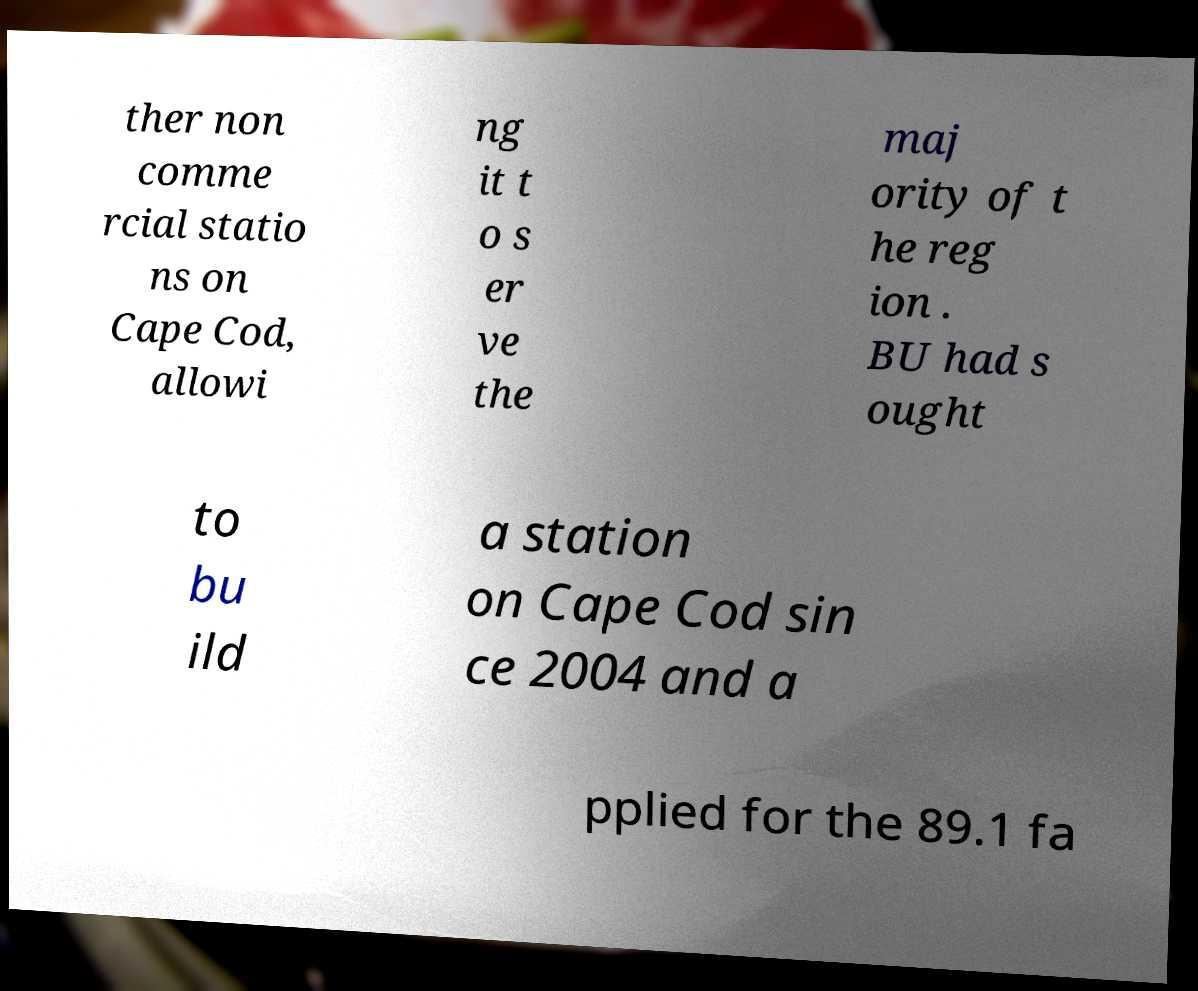There's text embedded in this image that I need extracted. Can you transcribe it verbatim? ther non comme rcial statio ns on Cape Cod, allowi ng it t o s er ve the maj ority of t he reg ion . BU had s ought to bu ild a station on Cape Cod sin ce 2004 and a pplied for the 89.1 fa 